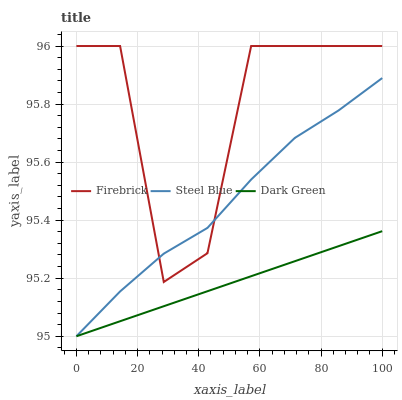Does Dark Green have the minimum area under the curve?
Answer yes or no. Yes. Does Firebrick have the maximum area under the curve?
Answer yes or no. Yes. Does Steel Blue have the minimum area under the curve?
Answer yes or no. No. Does Steel Blue have the maximum area under the curve?
Answer yes or no. No. Is Dark Green the smoothest?
Answer yes or no. Yes. Is Firebrick the roughest?
Answer yes or no. Yes. Is Steel Blue the smoothest?
Answer yes or no. No. Is Steel Blue the roughest?
Answer yes or no. No. Does Steel Blue have the lowest value?
Answer yes or no. Yes. Does Firebrick have the highest value?
Answer yes or no. Yes. Does Steel Blue have the highest value?
Answer yes or no. No. Is Dark Green less than Firebrick?
Answer yes or no. Yes. Is Firebrick greater than Dark Green?
Answer yes or no. Yes. Does Steel Blue intersect Firebrick?
Answer yes or no. Yes. Is Steel Blue less than Firebrick?
Answer yes or no. No. Is Steel Blue greater than Firebrick?
Answer yes or no. No. Does Dark Green intersect Firebrick?
Answer yes or no. No. 